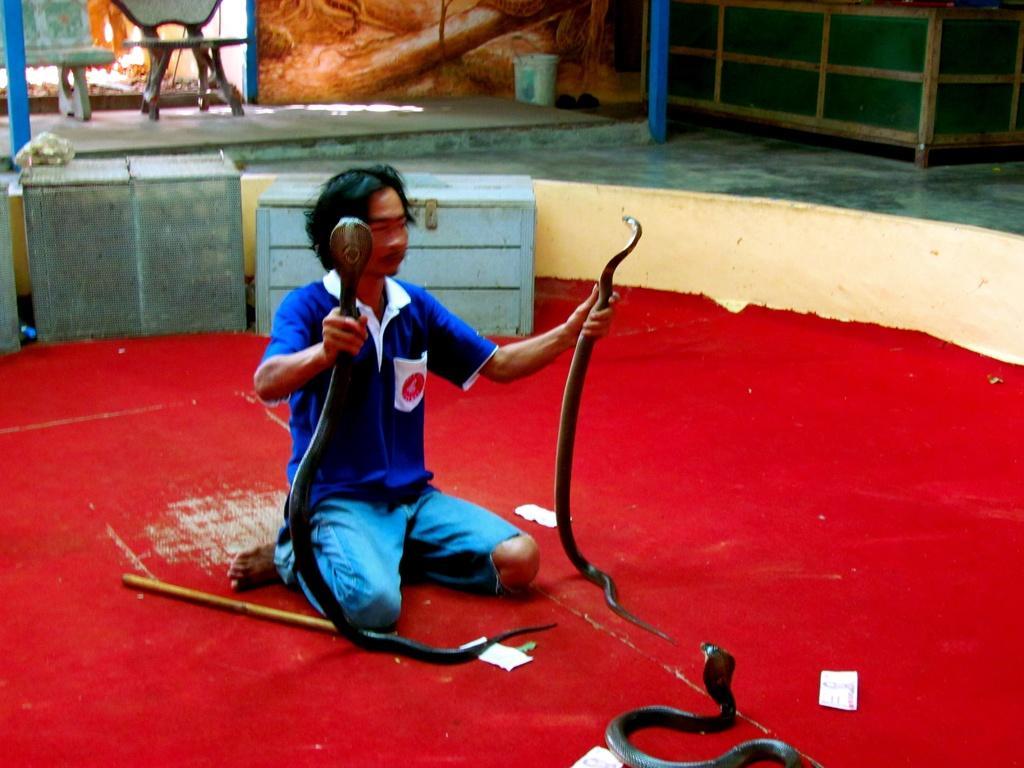In one or two sentences, can you explain what this image depicts? In this picture I can see a man sitting in front and I see that he is holding 2 snakes and I can see another snake in front of him and side to him I can see a stick. In the background I can see few containers and I can see a chair. 